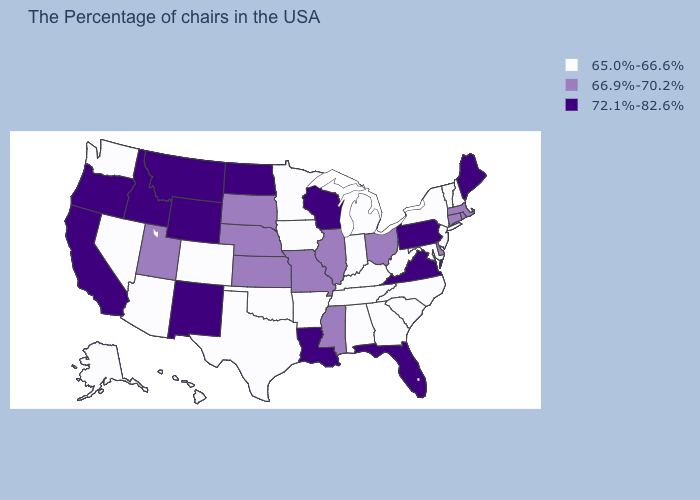What is the highest value in the USA?
Quick response, please. 72.1%-82.6%. Name the states that have a value in the range 72.1%-82.6%?
Concise answer only. Maine, Pennsylvania, Virginia, Florida, Wisconsin, Louisiana, North Dakota, Wyoming, New Mexico, Montana, Idaho, California, Oregon. Is the legend a continuous bar?
Give a very brief answer. No. What is the value of Kentucky?
Quick response, please. 65.0%-66.6%. Name the states that have a value in the range 65.0%-66.6%?
Give a very brief answer. New Hampshire, Vermont, New York, New Jersey, Maryland, North Carolina, South Carolina, West Virginia, Georgia, Michigan, Kentucky, Indiana, Alabama, Tennessee, Arkansas, Minnesota, Iowa, Oklahoma, Texas, Colorado, Arizona, Nevada, Washington, Alaska, Hawaii. What is the highest value in the USA?
Keep it brief. 72.1%-82.6%. Name the states that have a value in the range 65.0%-66.6%?
Quick response, please. New Hampshire, Vermont, New York, New Jersey, Maryland, North Carolina, South Carolina, West Virginia, Georgia, Michigan, Kentucky, Indiana, Alabama, Tennessee, Arkansas, Minnesota, Iowa, Oklahoma, Texas, Colorado, Arizona, Nevada, Washington, Alaska, Hawaii. Which states have the lowest value in the South?
Keep it brief. Maryland, North Carolina, South Carolina, West Virginia, Georgia, Kentucky, Alabama, Tennessee, Arkansas, Oklahoma, Texas. Does the first symbol in the legend represent the smallest category?
Give a very brief answer. Yes. What is the value of Minnesota?
Keep it brief. 65.0%-66.6%. Name the states that have a value in the range 72.1%-82.6%?
Quick response, please. Maine, Pennsylvania, Virginia, Florida, Wisconsin, Louisiana, North Dakota, Wyoming, New Mexico, Montana, Idaho, California, Oregon. Does the first symbol in the legend represent the smallest category?
Answer briefly. Yes. Name the states that have a value in the range 66.9%-70.2%?
Quick response, please. Massachusetts, Rhode Island, Connecticut, Delaware, Ohio, Illinois, Mississippi, Missouri, Kansas, Nebraska, South Dakota, Utah. What is the value of Iowa?
Answer briefly. 65.0%-66.6%. Which states have the highest value in the USA?
Keep it brief. Maine, Pennsylvania, Virginia, Florida, Wisconsin, Louisiana, North Dakota, Wyoming, New Mexico, Montana, Idaho, California, Oregon. 